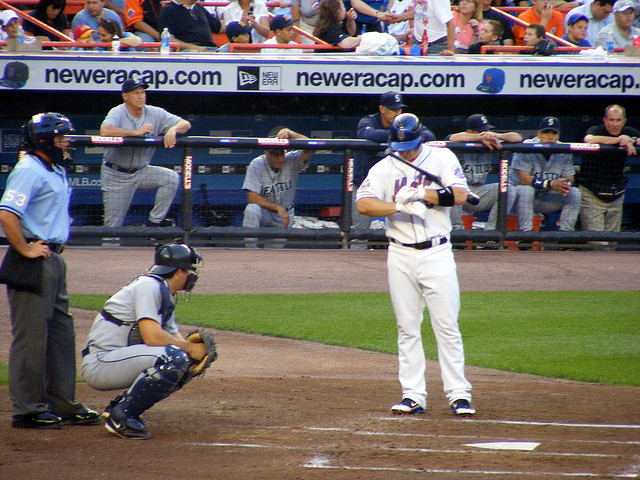Please extract the text content from this image. neweracap.com neweracap.com ERR 53 neweracap. S 